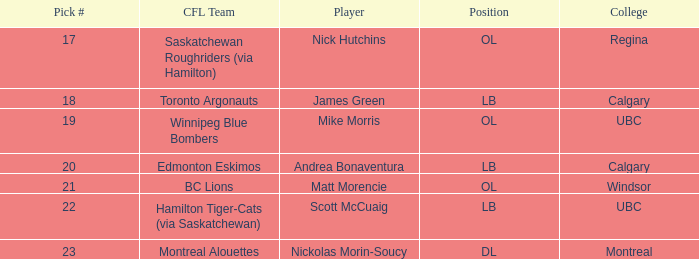What number picks were the players who went to Calgary?  18, 20. 